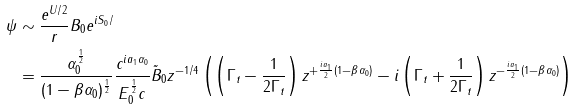Convert formula to latex. <formula><loc_0><loc_0><loc_500><loc_500>\psi & \sim \frac { e ^ { U / 2 } } { r } B _ { 0 } e ^ { i S _ { 0 } / } \\ & = \frac { \alpha _ { 0 } ^ { \frac { 1 } { 2 } } } { ( 1 - \beta \alpha _ { 0 } ) ^ { \frac { 1 } { 2 } } } \frac { c ^ { i a _ { 1 } \alpha _ { 0 } } } { E _ { 0 } ^ { \frac { 1 } { 2 } } c } \tilde { B } _ { 0 } z ^ { - 1 / 4 } \left ( \left ( \Gamma _ { t } - \frac { 1 } { 2 \Gamma _ { t } } \right ) z ^ { + \frac { i a _ { 1 } } { 2 } ( 1 - \beta \alpha _ { 0 } ) } - i \left ( \Gamma _ { t } + \frac { 1 } { 2 \Gamma _ { t } } \right ) z ^ { - \frac { i a _ { 1 } } { 2 } ( 1 - \beta \alpha _ { 0 } ) } \right )</formula> 